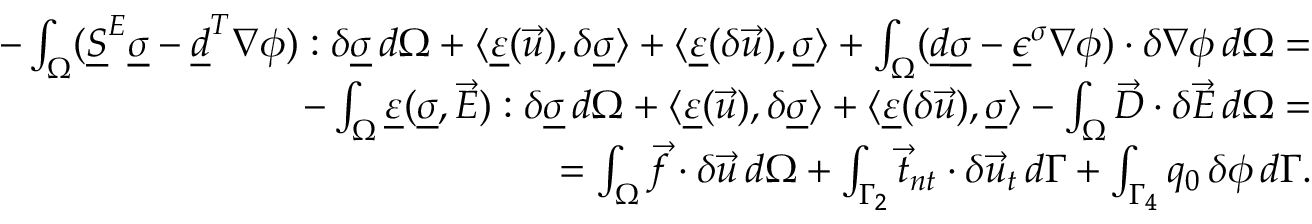Convert formula to latex. <formula><loc_0><loc_0><loc_500><loc_500>\begin{array} { r l } { - \int _ { \Omega } ( \underline { S } ^ { E } \underline { \sigma } - \underline { d } ^ { T } \nabla \phi ) \colon \delta \underline { \sigma } \, d \Omega + \langle \underline { \varepsilon } ( \vec { u } ) , \delta \underline { \sigma } \rangle + \langle \underline { \varepsilon } ( \delta \vec { u } ) , \underline { \sigma } \rangle + \int _ { \Omega } ( \underline { d } \underline { \sigma } - \underline { \epsilon } ^ { \sigma } \nabla \phi ) \cdot \delta \nabla \phi \, d \Omega = } \\ { - \int _ { \Omega } \underline { \varepsilon } ( \underline { \sigma } , \vec { E } ) \colon \delta \underline { \sigma } \, d \Omega + \langle \underline { \varepsilon } ( \vec { u } ) , \delta \underline { \sigma } \rangle + \langle \underline { \varepsilon } ( \delta \vec { u } ) , \underline { \sigma } \rangle - \int _ { \Omega } \vec { D } \cdot \delta \vec { E } \, d \Omega = } \\ { = \int _ { \Omega } \vec { f } \cdot \delta \vec { u } \, d \Omega + \int _ { \Gamma _ { 2 } } \vec { t } _ { n t } \cdot \delta \vec { u } _ { t } \, d \Gamma + \int _ { \Gamma _ { 4 } } q _ { 0 } \, \delta \phi \, d \Gamma . } \end{array}</formula> 